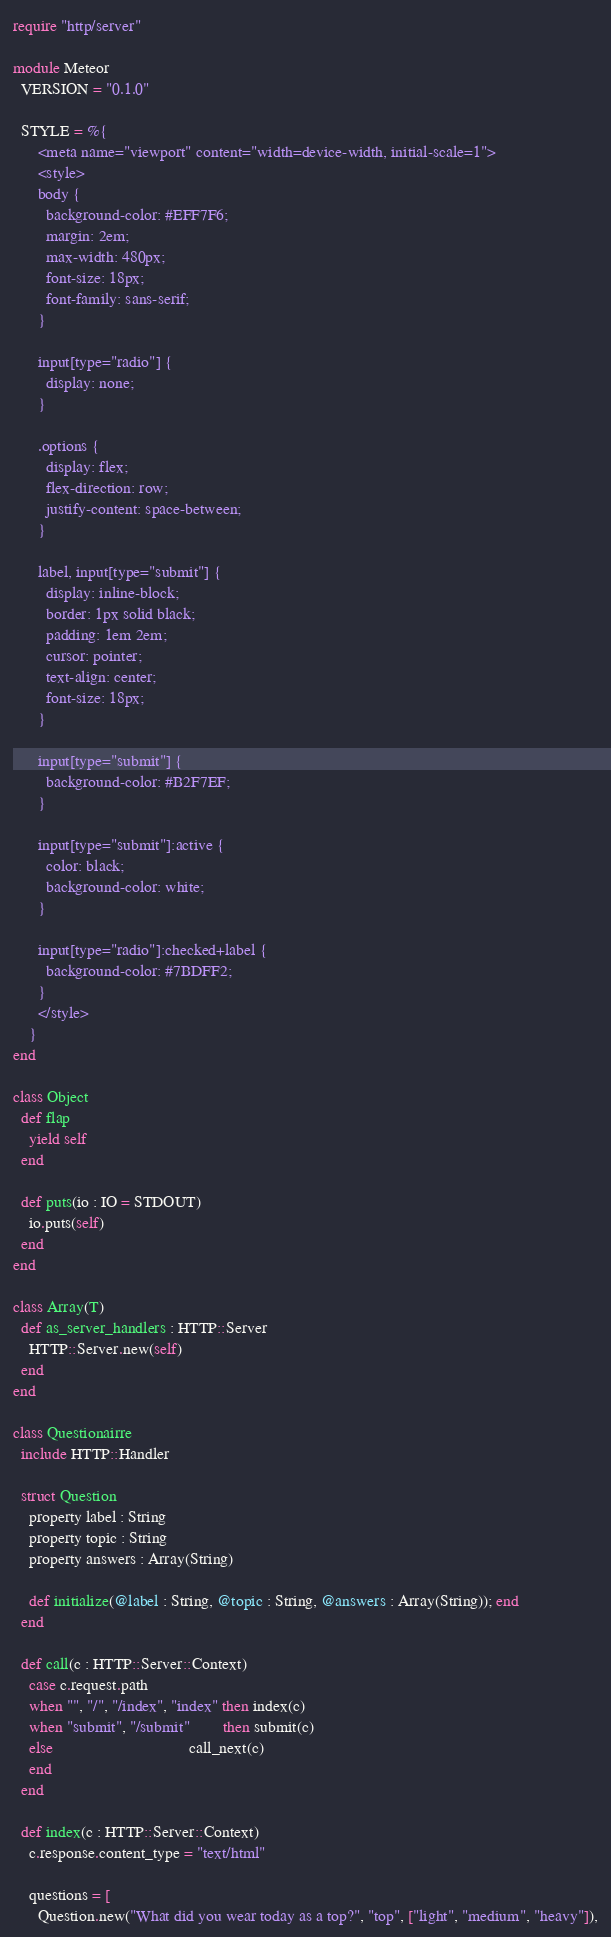<code> <loc_0><loc_0><loc_500><loc_500><_Crystal_>require "http/server"

module Meteor
  VERSION = "0.1.0"

  STYLE = %{
      <meta name="viewport" content="width=device-width, initial-scale=1">
      <style>
      body {
        background-color: #EFF7F6;
        margin: 2em;
        max-width: 480px;
        font-size: 18px;
        font-family: sans-serif;
      }

      input[type="radio"] {
        display: none;
      }

      .options {
        display: flex;
        flex-direction: row;
        justify-content: space-between;
      }

      label, input[type="submit"] {
        display: inline-block;
        border: 1px solid black;
        padding: 1em 2em;
        cursor: pointer;
        text-align: center;
        font-size: 18px;
      }

      input[type="submit"] {
        background-color: #B2F7EF;
      }

      input[type="submit"]:active {
        color: black;
        background-color: white;
      }

      input[type="radio"]:checked+label {
        background-color: #7BDFF2;
      }
      </style>
    }
end

class Object
  def flap
    yield self
  end

  def puts(io : IO = STDOUT)
    io.puts(self)
  end
end

class Array(T)
  def as_server_handlers : HTTP::Server
    HTTP::Server.new(self)
  end
end

class Questionairre
  include HTTP::Handler

  struct Question
    property label : String
    property topic : String
    property answers : Array(String)

    def initialize(@label : String, @topic : String, @answers : Array(String)); end
  end

  def call(c : HTTP::Server::Context)
    case c.request.path
    when "", "/", "/index", "index" then index(c)
    when "submit", "/submit"        then submit(c)
    else                                 call_next(c)
    end
  end

  def index(c : HTTP::Server::Context)
    c.response.content_type = "text/html"

    questions = [
      Question.new("What did you wear today as a top?", "top", ["light", "medium", "heavy"]),</code> 